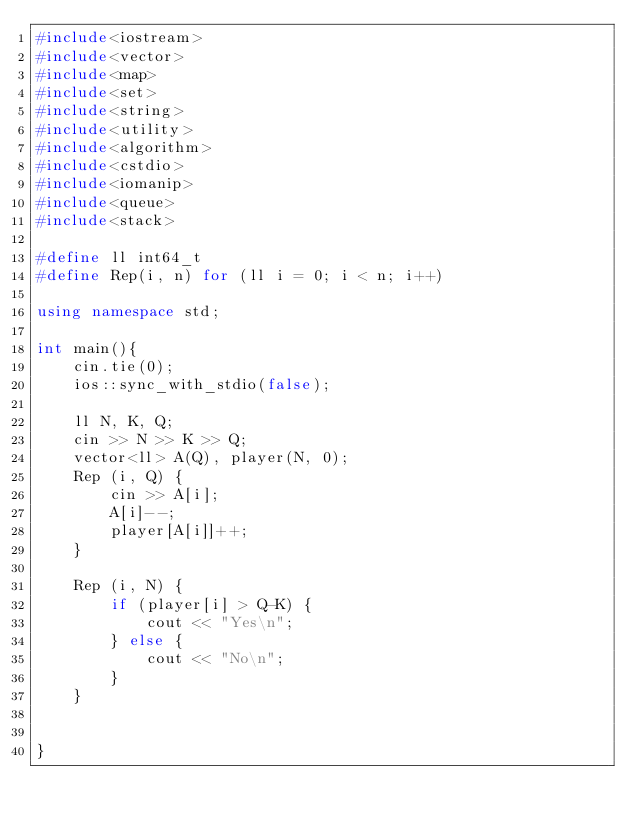Convert code to text. <code><loc_0><loc_0><loc_500><loc_500><_C++_>#include<iostream>
#include<vector>
#include<map>
#include<set>
#include<string>
#include<utility>
#include<algorithm>
#include<cstdio>
#include<iomanip>
#include<queue>
#include<stack>

#define ll int64_t
#define Rep(i, n) for (ll i = 0; i < n; i++)

using namespace std;

int main(){
    cin.tie(0);
    ios::sync_with_stdio(false);

    ll N, K, Q;
    cin >> N >> K >> Q;
    vector<ll> A(Q), player(N, 0);
    Rep (i, Q) {
        cin >> A[i];
        A[i]--;
        player[A[i]]++;
    }

    Rep (i, N) {
        if (player[i] > Q-K) {
            cout << "Yes\n";
        } else {
            cout << "No\n";
        }
    }

    
}</code> 